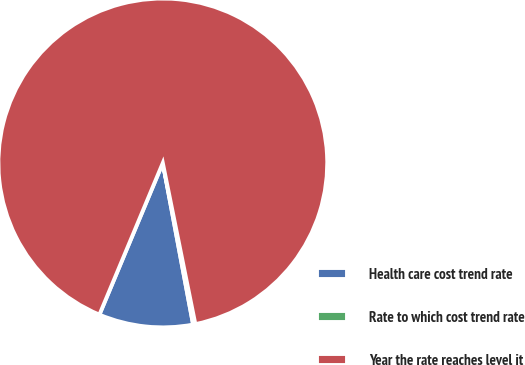<chart> <loc_0><loc_0><loc_500><loc_500><pie_chart><fcel>Health care cost trend rate<fcel>Rate to which cost trend rate<fcel>Year the rate reaches level it<nl><fcel>9.25%<fcel>0.22%<fcel>90.52%<nl></chart> 